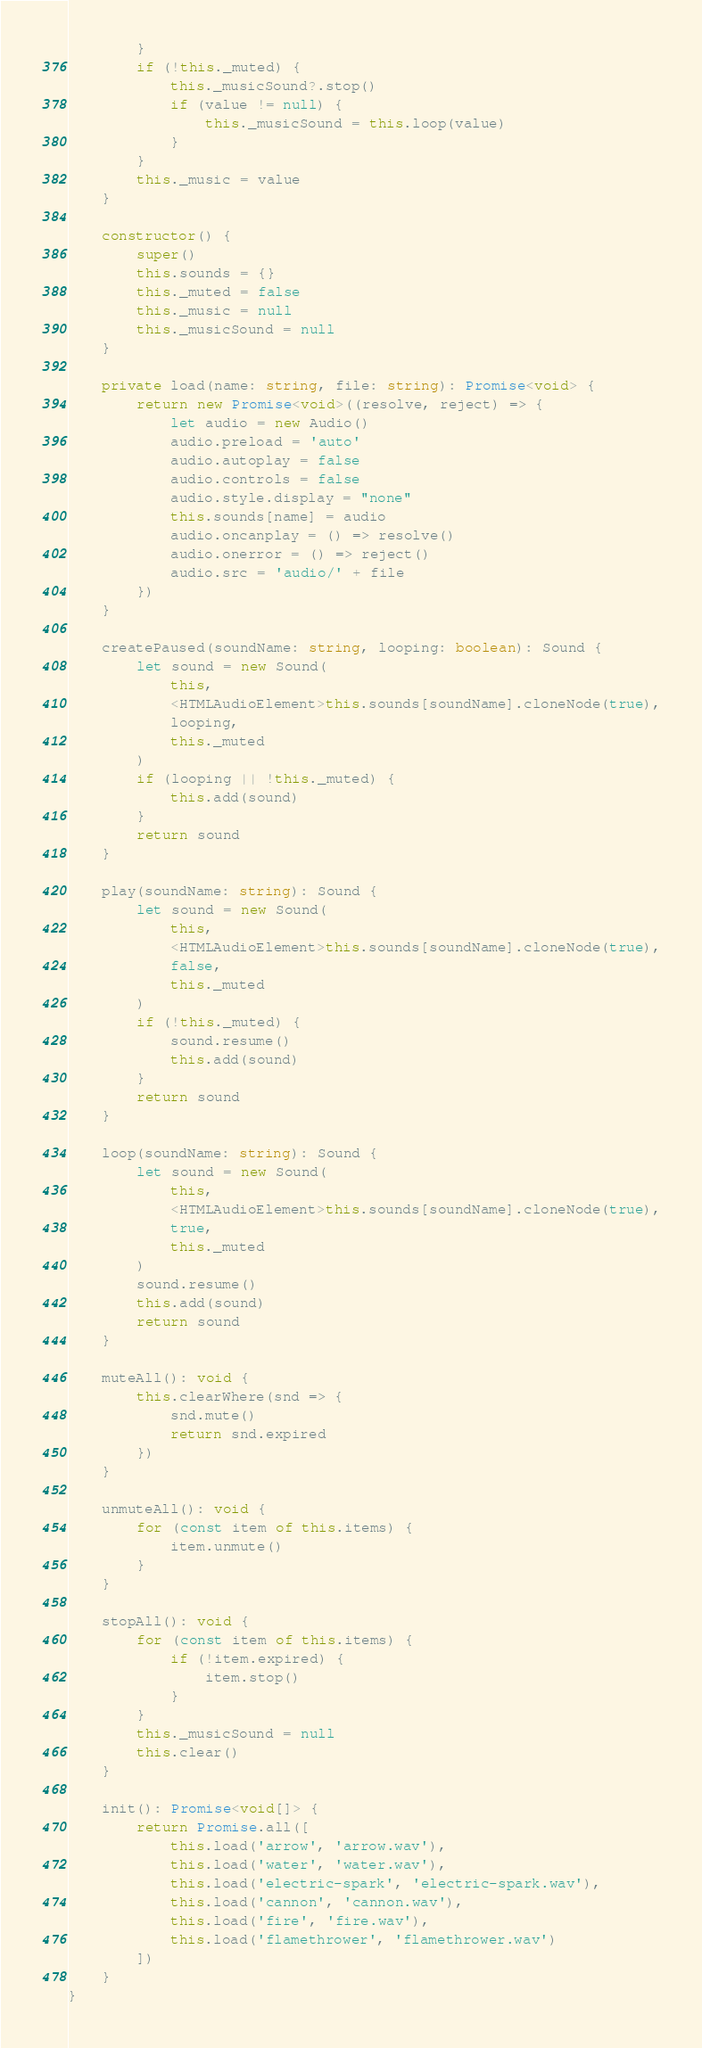Convert code to text. <code><loc_0><loc_0><loc_500><loc_500><_TypeScript_>        }
        if (!this._muted) {
            this._musicSound?.stop()
            if (value != null) {
                this._musicSound = this.loop(value)
            }
        }
        this._music = value
    }

    constructor() {
        super()
        this.sounds = {}
        this._muted = false
        this._music = null
        this._musicSound = null
    }

    private load(name: string, file: string): Promise<void> {
        return new Promise<void>((resolve, reject) => {
            let audio = new Audio()
            audio.preload = 'auto'
            audio.autoplay = false
            audio.controls = false
            audio.style.display = "none"
            this.sounds[name] = audio
            audio.oncanplay = () => resolve()
            audio.onerror = () => reject()
            audio.src = 'audio/' + file
        })
    }

    createPaused(soundName: string, looping: boolean): Sound {
        let sound = new Sound(
            this,
            <HTMLAudioElement>this.sounds[soundName].cloneNode(true),
            looping,
            this._muted
        )
        if (looping || !this._muted) {
            this.add(sound)
        }
        return sound
    }

    play(soundName: string): Sound {
        let sound = new Sound(
            this,
            <HTMLAudioElement>this.sounds[soundName].cloneNode(true),
            false,
            this._muted
        )
        if (!this._muted) {
            sound.resume()
            this.add(sound)
        }
        return sound
    }

    loop(soundName: string): Sound {
        let sound = new Sound(
            this,
            <HTMLAudioElement>this.sounds[soundName].cloneNode(true),
            true,
            this._muted
        )
        sound.resume()
        this.add(sound)
        return sound
    }

    muteAll(): void {
        this.clearWhere(snd => {
            snd.mute()
            return snd.expired
        })
    }

    unmuteAll(): void {
        for (const item of this.items) {
            item.unmute()
        }
    }

    stopAll(): void {
        for (const item of this.items) {
            if (!item.expired) {
                item.stop()
            }
        }
        this._musicSound = null
        this.clear()
    }

    init(): Promise<void[]> {
        return Promise.all([
            this.load('arrow', 'arrow.wav'),
            this.load('water', 'water.wav'),
            this.load('electric-spark', 'electric-spark.wav'),
            this.load('cannon', 'cannon.wav'),
            this.load('fire', 'fire.wav'),
            this.load('flamethrower', 'flamethrower.wav')
        ])
    }
}
</code> 